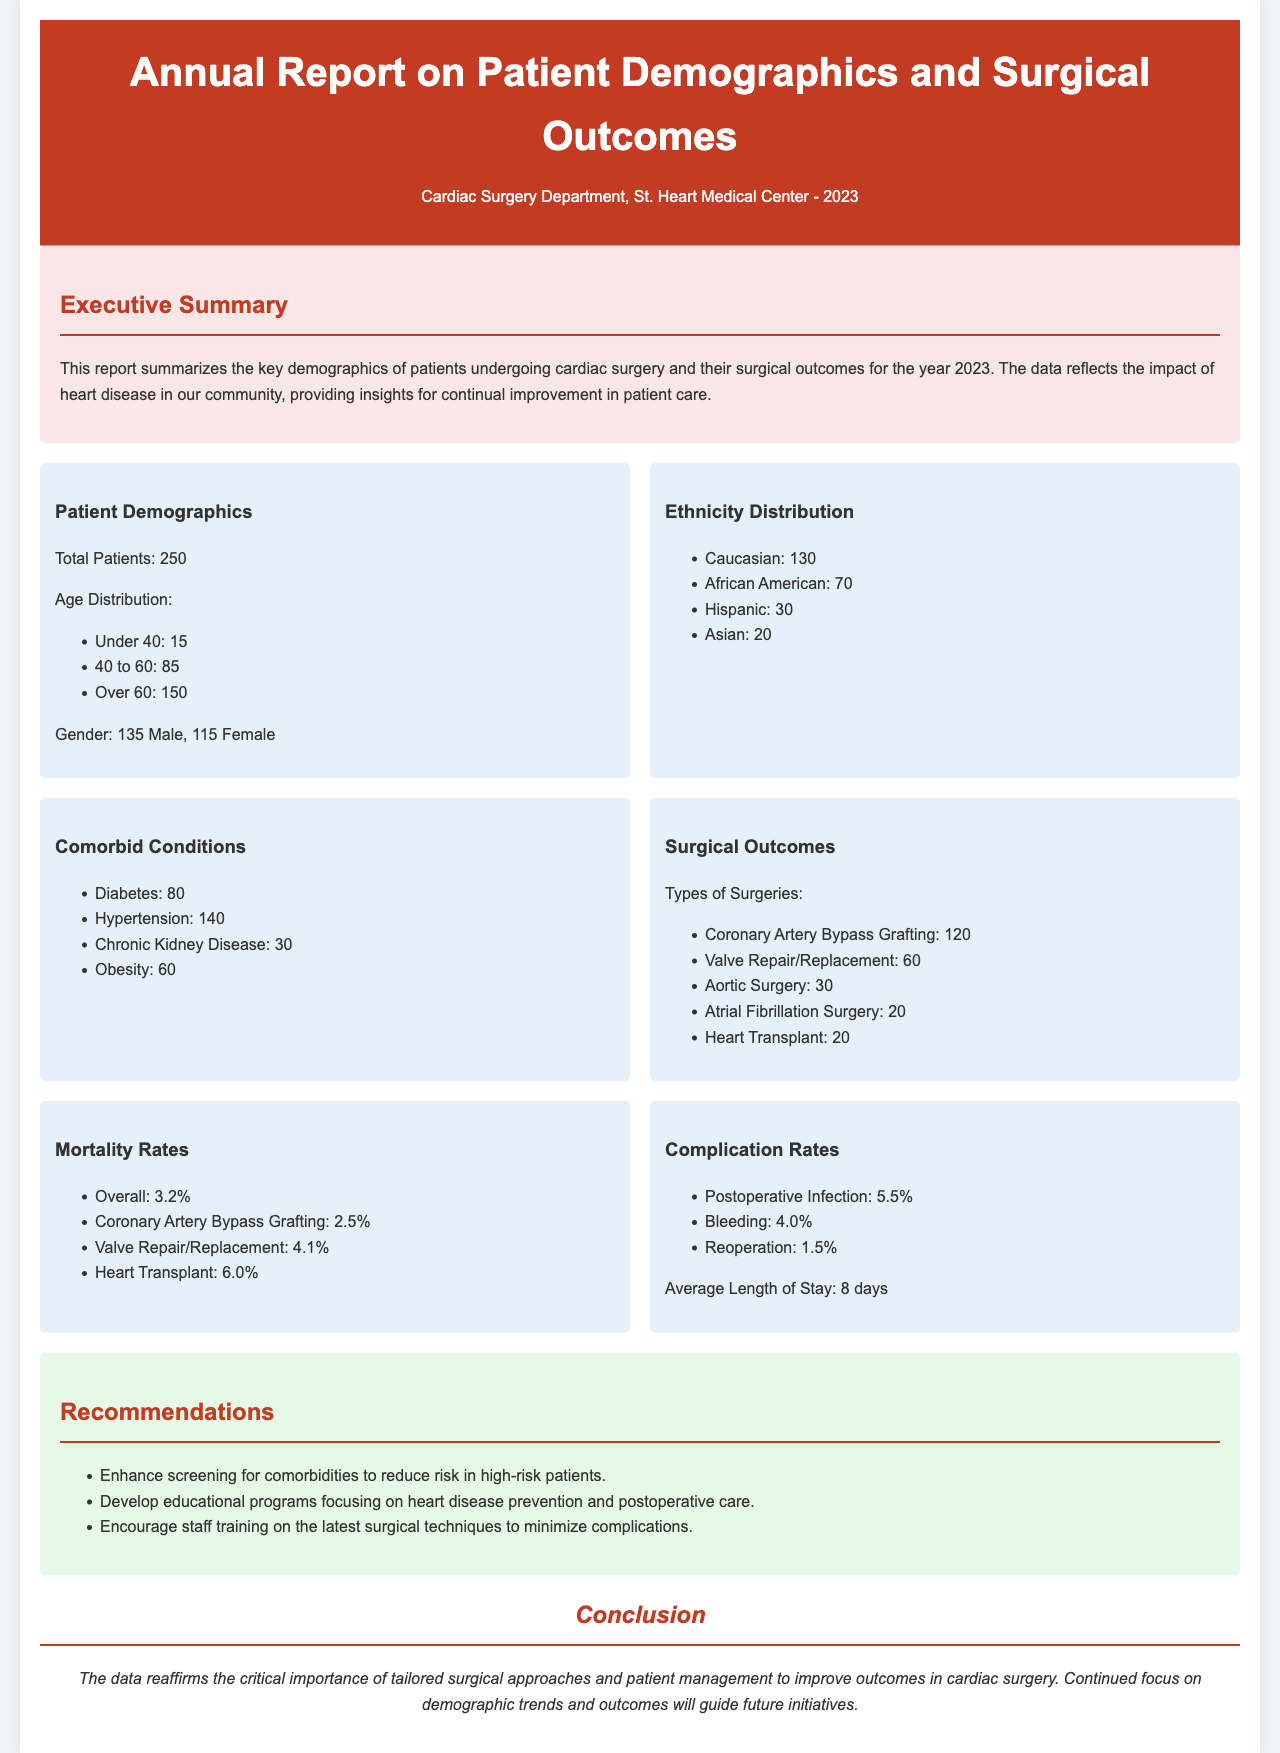What is the total number of patients? The total number of patients is directly provided in the statistics section of the report.
Answer: 250 What is the age group with the highest number of patients? The age distribution lists the number of patients in each group, making it clear which has the highest count.
Answer: Over 60 What percentage of patients underwent coronary artery bypass grafting? The number of surgeries performed is available, which can be used to calculate the percentage of coronary artery bypass grafting among the total patients.
Answer: 48% What is the mortality rate for valve repair/replacement? The mortality rates section explicitly states the mortality rate for this type of surgery.
Answer: 4.1% How many patients have diabetes? The comorbid conditions section includes the exact number of patients with diabetes.
Answer: 80 What is the average length of stay for patients? The average length of stay is mentioned in the complications rates section.
Answer: 8 days Which demographic has the highest representation among patients? The ethnicity distribution section lists the number of patients from each demographic group, allowing identification of the highest one.
Answer: Caucasian What recommendation is made concerning staff training? The recommendations section includes specific suggestions for staff training that are directly related to minimizing complications.
Answer: Enhance staff training on the latest surgical techniques 